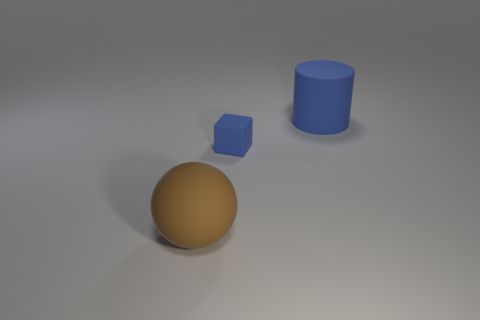What number of other things are there of the same shape as the big brown thing?
Offer a very short reply. 0. Are there any small blue blocks on the right side of the tiny rubber block?
Provide a short and direct response. No. The big matte cylinder has what color?
Provide a succinct answer. Blue. Do the rubber cube and the large object that is to the left of the blue rubber cube have the same color?
Keep it short and to the point. No. Is there a matte cylinder of the same size as the brown sphere?
Provide a short and direct response. Yes. What is the size of the matte cylinder that is the same color as the rubber cube?
Ensure brevity in your answer.  Large. What is the big cylinder behind the tiny blue cube made of?
Provide a succinct answer. Rubber. Are there an equal number of blue rubber blocks on the right side of the blue rubber block and large rubber things that are in front of the brown sphere?
Keep it short and to the point. Yes. There is a blue object to the right of the tiny blue thing; does it have the same size as the blue matte object that is left of the big blue thing?
Ensure brevity in your answer.  No. What number of tiny matte cubes have the same color as the big cylinder?
Your answer should be very brief. 1. 